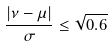Convert formula to latex. <formula><loc_0><loc_0><loc_500><loc_500>\frac { | \nu - \mu | } { \sigma } \leq \sqrt { 0 . 6 }</formula> 